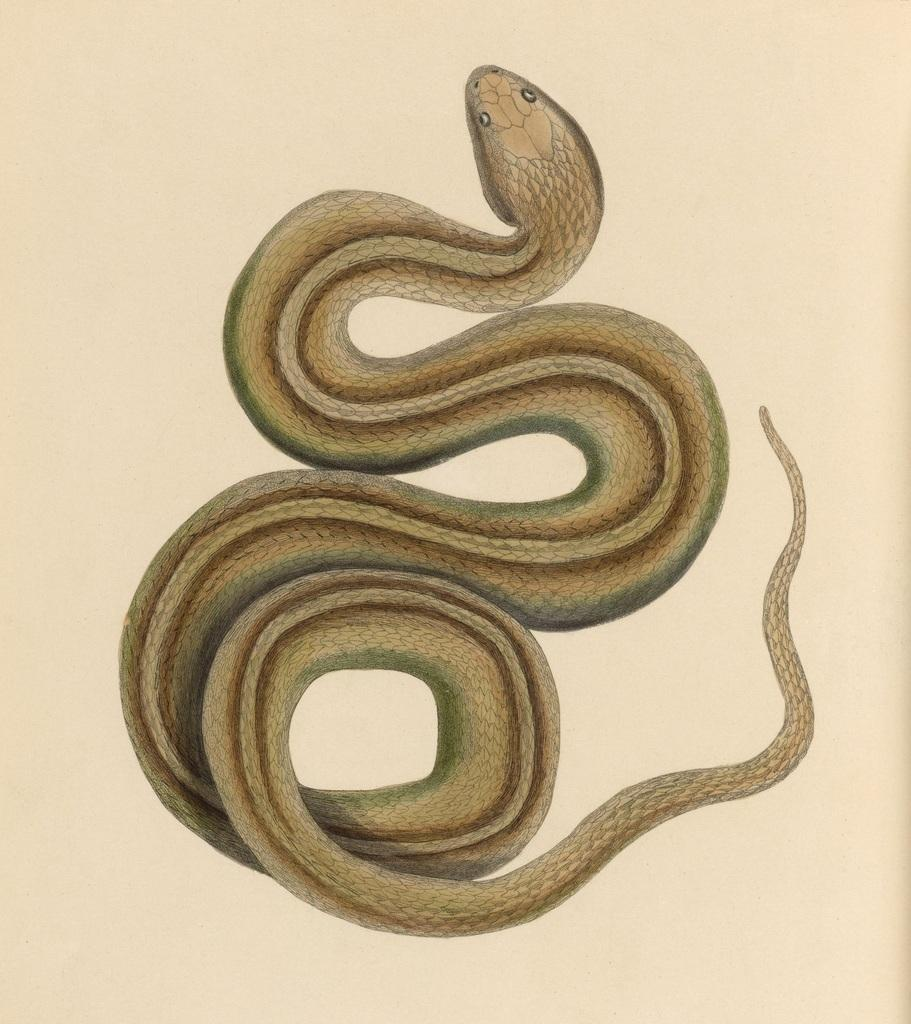What is the main subject of the image? There is a painting in the image. What is depicted in the painting? The painting depicts a snake. How many women are attacking the snake in the painting? There are no women present in the painting, nor is there any indication of an attack. 